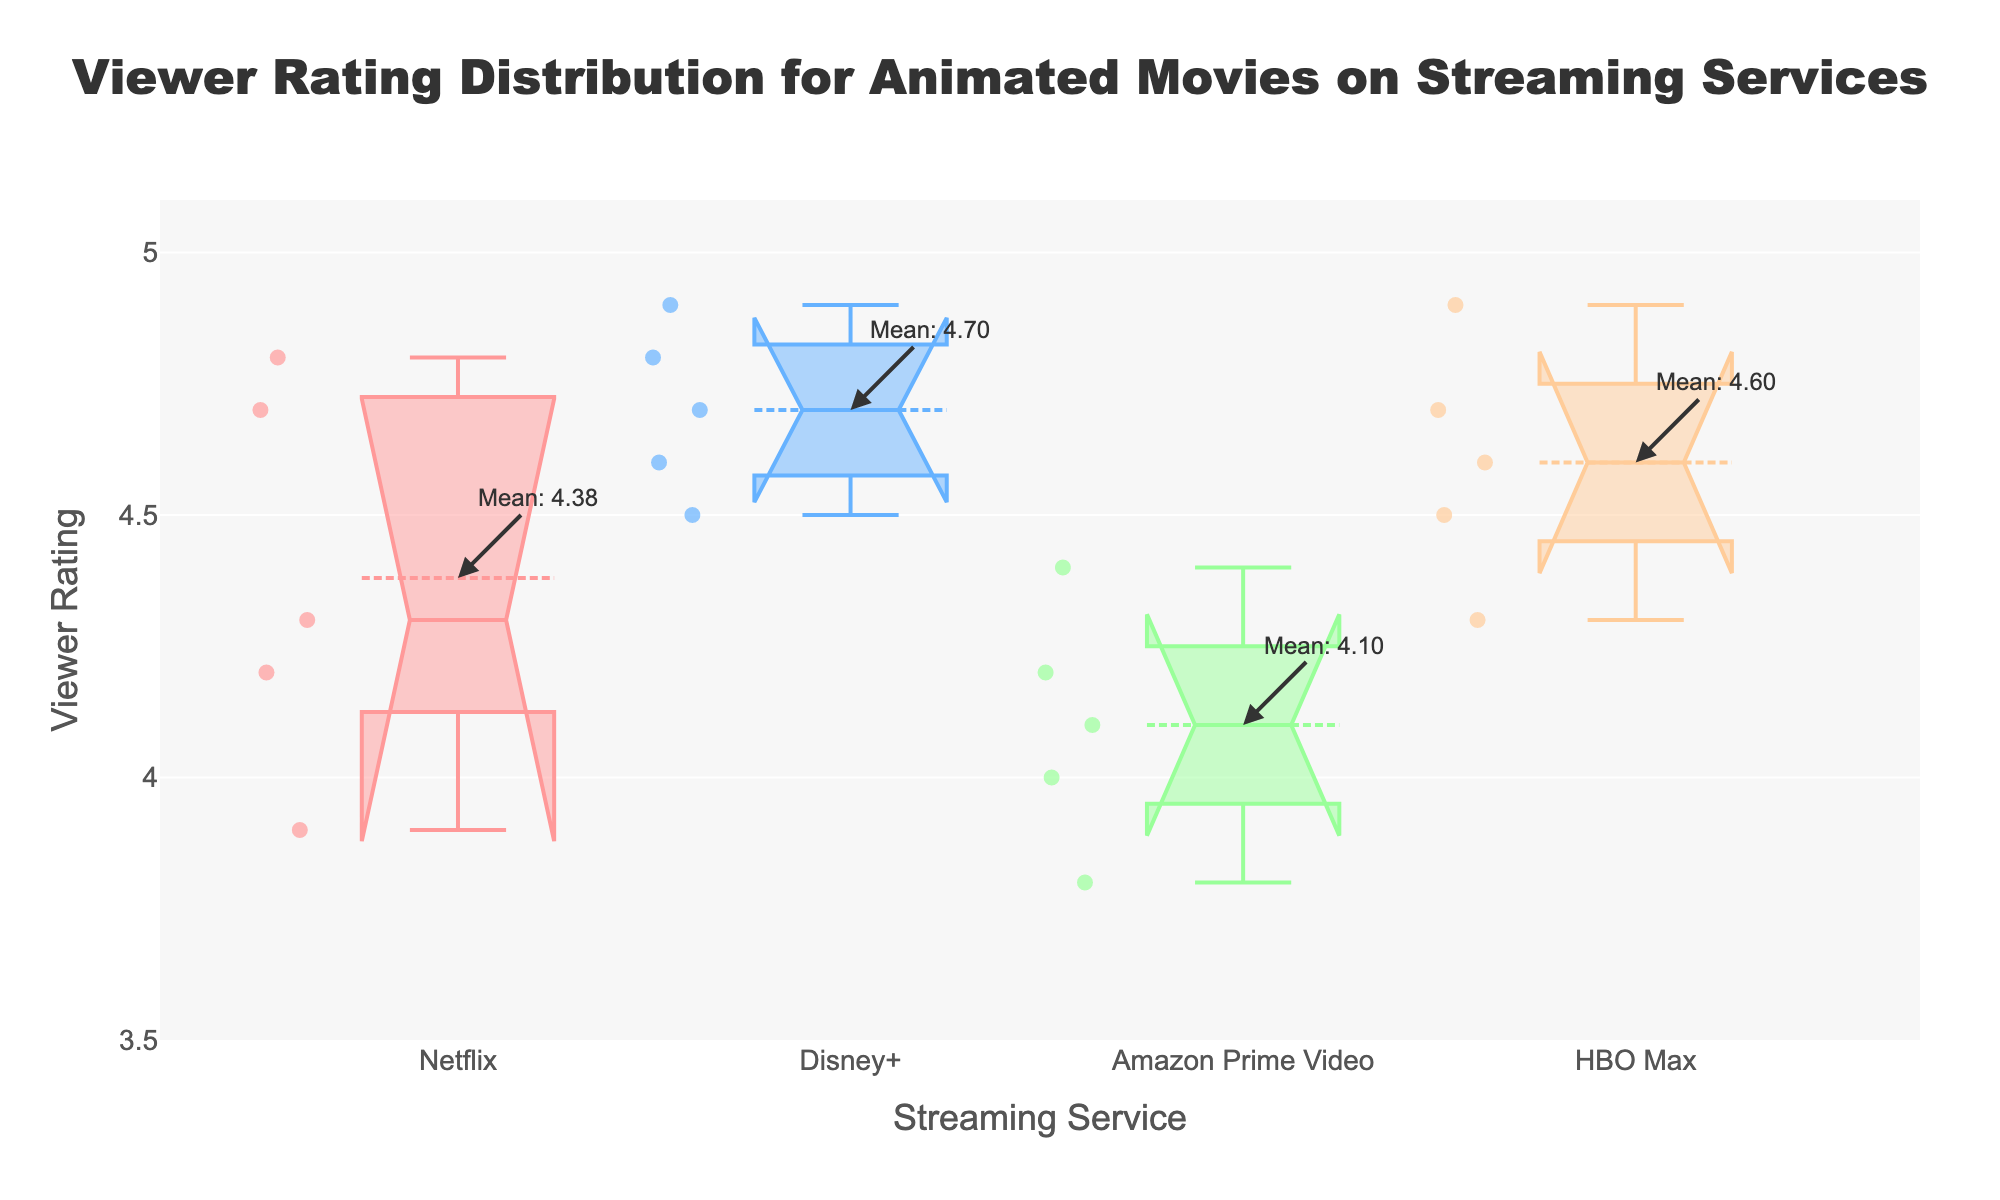what is the title of the figure? The title is usually at the top of the figure. It reads "Viewer Rating Distribution for Animated Movies on Streaming Services".
Answer: "Viewer Rating Distribution for Animated Movies on Streaming Services" how many streaming services are compared in the figure? The different colors and labels on the x-axis represent the various streaming services. Here, we see Netflix, Disney+, Amazon Prime Video, and HBO Max, totaling four services.
Answer: four which service has the highest mean rating? The mean is indicated by annotations on the box plots. HBO Max has the highest annoted mean rating.
Answer: HBO Max which service has the widest interquartile range (IQR)? The IQR is the range between the first and third quartiles in each box. By comparing the boxes visually, Netflix has the widest IQR.
Answer: Netflix what streaming service has the smallest median viewer rating range? The median is the line inside the box plot. By comparing the notches which signify the confidence interval around the median, HBO Max appears to have the smallest range.
Answer: HBO Max which streaming service shows the most variability in viewer ratings? The variability is indicated by the length of the whiskers and the presence of outliers. Disney+ shows the most variability, as it has the longest whiskers.
Answer: Disney+ how does the median viewer rating for Netflix compare to Amazon Prime Video? The median is the line inside the box plot. Comparing the positions of these lines for both services, Netflix has a higher median viewer rating than Amazon Prime Video.
Answer: Netflix has a higher median what does the notch in a box plot represent, and how do they compare across services? The notch represents the 95% confidence interval around the median. When the notches of two boxes do not overlap, it suggests a significant difference. Here, none of the notches overlap significantly, indicating slight differences in medians.
Answer: It signifies a 95% confidence interval around the median; Slight differences in medians without significant differences which service appears to have an outlier? Outliers are indicated by points outside the whiskers. Amazon Prime Video has one clear outlier below its lower whisker.
Answer: Amazon Prime Video 